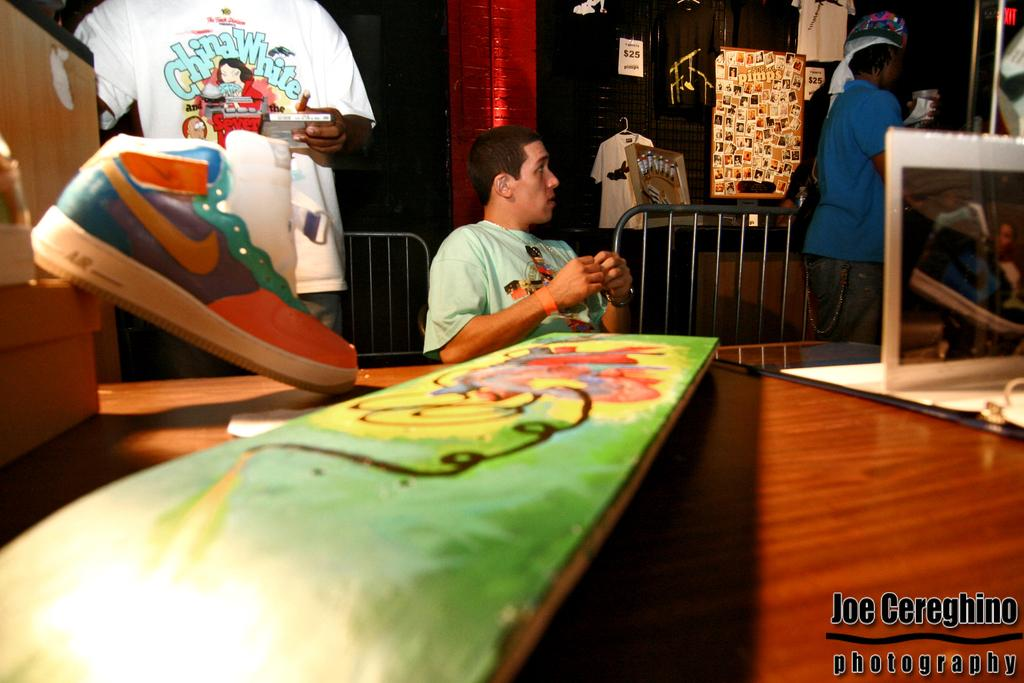<image>
Write a terse but informative summary of the picture. A man is wearing a white t-shirt that says China White on the front. 